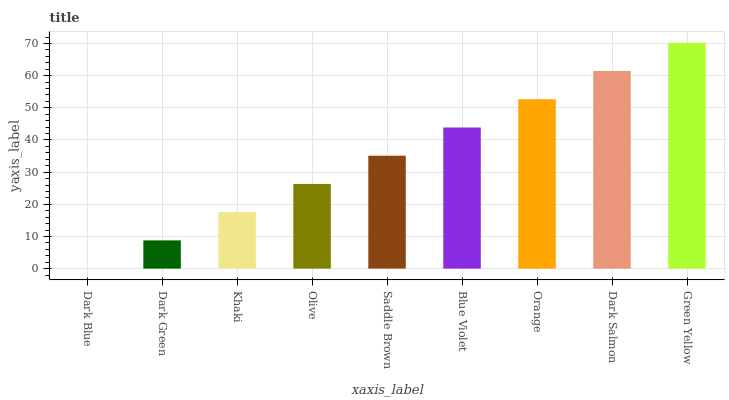Is Dark Green the minimum?
Answer yes or no. No. Is Dark Green the maximum?
Answer yes or no. No. Is Dark Green greater than Dark Blue?
Answer yes or no. Yes. Is Dark Blue less than Dark Green?
Answer yes or no. Yes. Is Dark Blue greater than Dark Green?
Answer yes or no. No. Is Dark Green less than Dark Blue?
Answer yes or no. No. Is Saddle Brown the high median?
Answer yes or no. Yes. Is Saddle Brown the low median?
Answer yes or no. Yes. Is Dark Salmon the high median?
Answer yes or no. No. Is Khaki the low median?
Answer yes or no. No. 